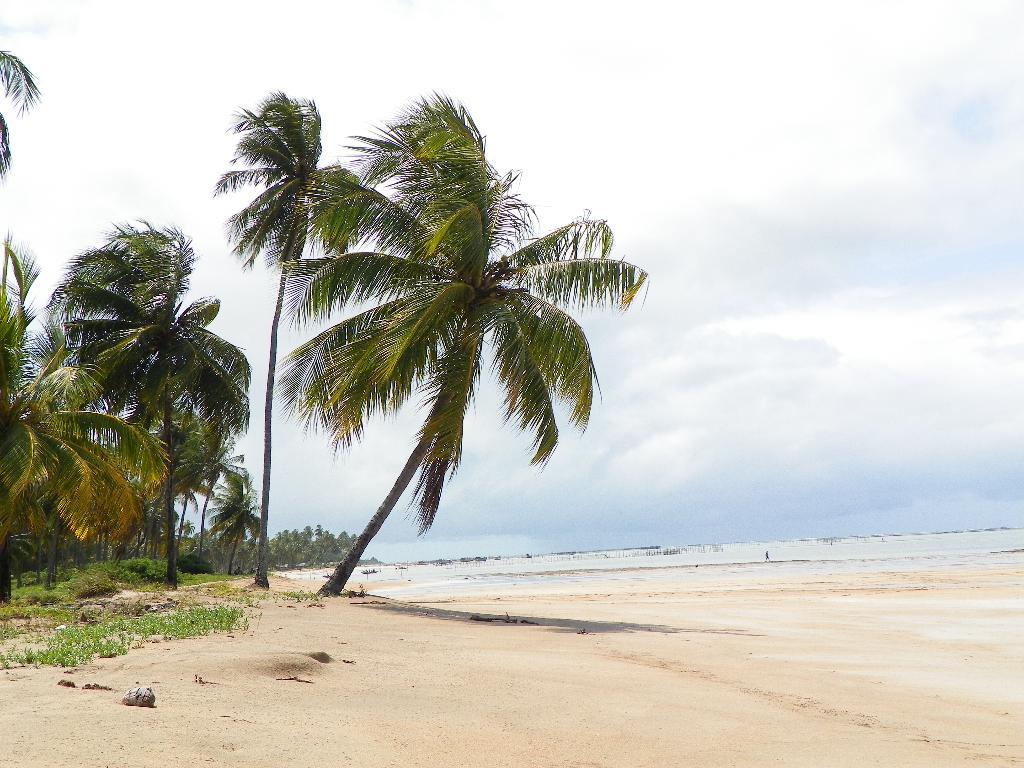Where was the image taken? The image was clicked near the beach. What can be seen at the bottom of the image? There is sand at the bottom of the image. What type of vegetation is visible to the left of the image? There are coconut trees to the left of the image. What is visible in the sky at the top of the image? There are clouds in the sky at the top of the image. What is present to the right of the image? There is water to the right of the image. What type of school can be seen in the image? There is no school present in the image; it features of a beach setting are visible instead. 